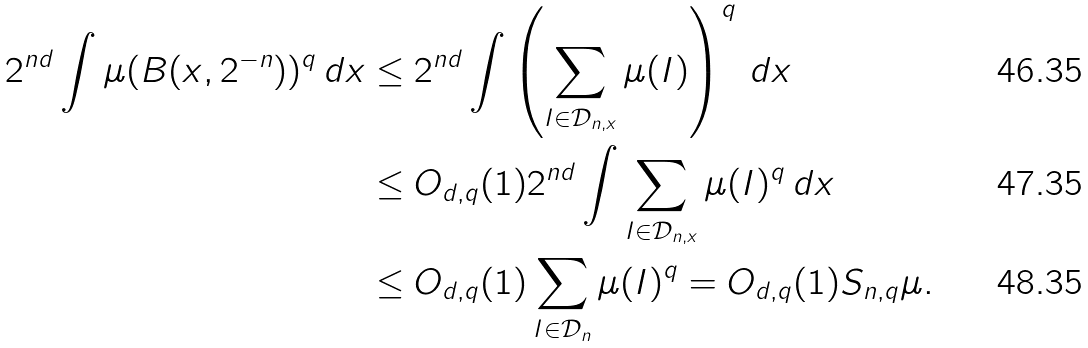Convert formula to latex. <formula><loc_0><loc_0><loc_500><loc_500>2 ^ { n d } \int \mu ( B ( x , 2 ^ { - n } ) ) ^ { q } \, d x & \leq 2 ^ { n d } \int \left ( \sum _ { I \in \mathcal { D } _ { n , x } } \mu ( I ) \right ) ^ { q } \, d x \\ & \leq O _ { d , q } ( 1 ) 2 ^ { n d } \int \sum _ { I \in \mathcal { D } _ { n , x } } \mu ( I ) ^ { q } \, d x \\ & \leq O _ { d , q } ( 1 ) \sum _ { I \in \mathcal { D } _ { n } } \mu ( I ) ^ { q } = O _ { d , q } ( 1 ) S _ { n , q } \mu .</formula> 